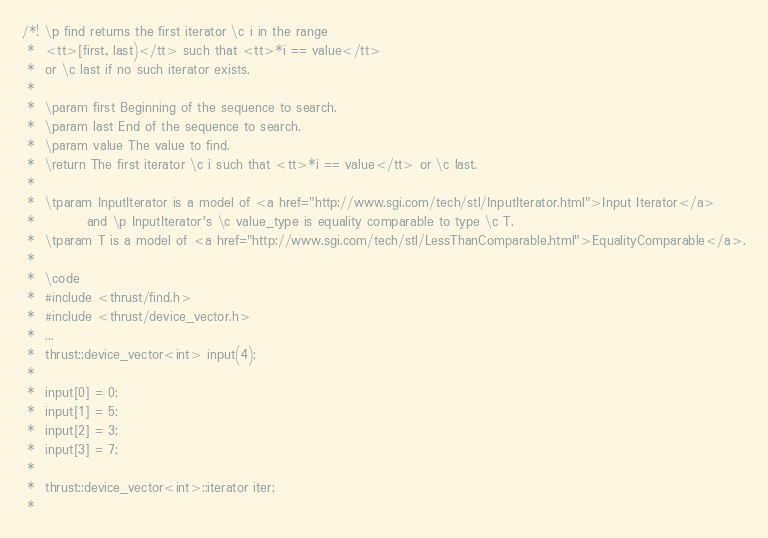<code> <loc_0><loc_0><loc_500><loc_500><_C_>

/*! \p find returns the first iterator \c i in the range
 *  <tt>[first, last)</tt> such that <tt>*i == value</tt>
 *  or \c last if no such iterator exists.
 *
 *  \param first Beginning of the sequence to search.
 *  \param last End of the sequence to search.
 *  \param value The value to find.
 *  \return The first iterator \c i such that <tt>*i == value</tt> or \c last.
 *
 *  \tparam InputIterator is a model of <a href="http://www.sgi.com/tech/stl/InputIterator.html">Input Iterator</a>
 *          and \p InputIterator's \c value_type is equality comparable to type \c T.
 *  \tparam T is a model of <a href="http://www.sgi.com/tech/stl/LessThanComparable.html">EqualityComparable</a>.
 *
 *  \code
 *  #include <thrust/find.h>
 *  #include <thrust/device_vector.h>
 *  ...
 *  thrust::device_vector<int> input(4);
 *
 *  input[0] = 0;
 *  input[1] = 5;
 *  input[2] = 3;
 *  input[3] = 7;
 *
 *  thrust::device_vector<int>::iterator iter;
 *</code> 